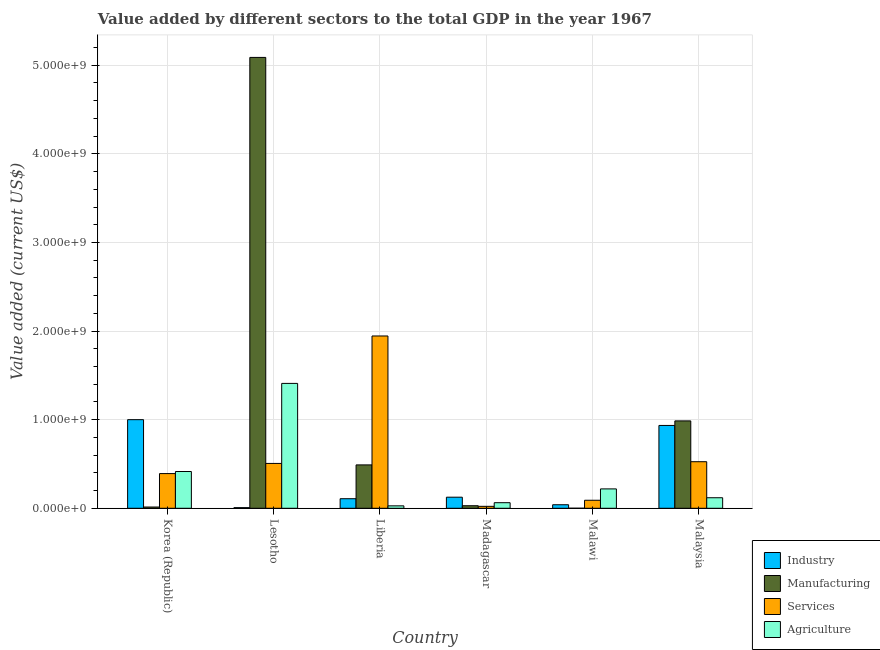How many different coloured bars are there?
Your response must be concise. 4. Are the number of bars on each tick of the X-axis equal?
Make the answer very short. Yes. How many bars are there on the 5th tick from the left?
Make the answer very short. 4. How many bars are there on the 5th tick from the right?
Make the answer very short. 4. What is the label of the 6th group of bars from the left?
Provide a succinct answer. Malaysia. In how many cases, is the number of bars for a given country not equal to the number of legend labels?
Your answer should be compact. 0. What is the value added by industrial sector in Lesotho?
Your answer should be compact. 6.99e+06. Across all countries, what is the maximum value added by industrial sector?
Provide a succinct answer. 1.00e+09. Across all countries, what is the minimum value added by industrial sector?
Offer a terse response. 6.99e+06. In which country was the value added by agricultural sector maximum?
Offer a very short reply. Lesotho. In which country was the value added by services sector minimum?
Give a very brief answer. Madagascar. What is the total value added by agricultural sector in the graph?
Provide a short and direct response. 2.25e+09. What is the difference between the value added by services sector in Korea (Republic) and that in Madagascar?
Keep it short and to the point. 3.70e+08. What is the difference between the value added by agricultural sector in Lesotho and the value added by industrial sector in Malawi?
Provide a short and direct response. 1.37e+09. What is the average value added by services sector per country?
Provide a short and direct response. 5.80e+08. What is the difference between the value added by manufacturing sector and value added by agricultural sector in Liberia?
Offer a terse response. 4.62e+08. In how many countries, is the value added by agricultural sector greater than 200000000 US$?
Ensure brevity in your answer.  3. What is the ratio of the value added by services sector in Liberia to that in Madagascar?
Offer a terse response. 88.78. Is the value added by manufacturing sector in Lesotho less than that in Malawi?
Make the answer very short. No. What is the difference between the highest and the second highest value added by services sector?
Your response must be concise. 1.42e+09. What is the difference between the highest and the lowest value added by industrial sector?
Give a very brief answer. 9.93e+08. In how many countries, is the value added by agricultural sector greater than the average value added by agricultural sector taken over all countries?
Your answer should be very brief. 2. Is the sum of the value added by industrial sector in Lesotho and Malawi greater than the maximum value added by services sector across all countries?
Offer a very short reply. No. Is it the case that in every country, the sum of the value added by industrial sector and value added by agricultural sector is greater than the sum of value added by manufacturing sector and value added by services sector?
Make the answer very short. No. What does the 4th bar from the left in Malaysia represents?
Offer a very short reply. Agriculture. What does the 3rd bar from the right in Madagascar represents?
Your answer should be compact. Manufacturing. How many bars are there?
Your answer should be very brief. 24. How many countries are there in the graph?
Make the answer very short. 6. What is the difference between two consecutive major ticks on the Y-axis?
Make the answer very short. 1.00e+09. Are the values on the major ticks of Y-axis written in scientific E-notation?
Your answer should be very brief. Yes. Does the graph contain any zero values?
Provide a short and direct response. No. Where does the legend appear in the graph?
Keep it short and to the point. Bottom right. How many legend labels are there?
Ensure brevity in your answer.  4. What is the title of the graph?
Offer a very short reply. Value added by different sectors to the total GDP in the year 1967. What is the label or title of the Y-axis?
Your response must be concise. Value added (current US$). What is the Value added (current US$) in Industry in Korea (Republic)?
Offer a terse response. 1.00e+09. What is the Value added (current US$) of Manufacturing in Korea (Republic)?
Make the answer very short. 1.41e+07. What is the Value added (current US$) of Services in Korea (Republic)?
Provide a succinct answer. 3.91e+08. What is the Value added (current US$) in Agriculture in Korea (Republic)?
Your response must be concise. 4.15e+08. What is the Value added (current US$) of Industry in Lesotho?
Keep it short and to the point. 6.99e+06. What is the Value added (current US$) in Manufacturing in Lesotho?
Your response must be concise. 5.09e+09. What is the Value added (current US$) of Services in Lesotho?
Provide a succinct answer. 5.06e+08. What is the Value added (current US$) in Agriculture in Lesotho?
Your answer should be compact. 1.41e+09. What is the Value added (current US$) in Industry in Liberia?
Keep it short and to the point. 1.08e+08. What is the Value added (current US$) of Manufacturing in Liberia?
Keep it short and to the point. 4.89e+08. What is the Value added (current US$) in Services in Liberia?
Offer a terse response. 1.94e+09. What is the Value added (current US$) of Agriculture in Liberia?
Your answer should be compact. 2.73e+07. What is the Value added (current US$) in Industry in Madagascar?
Offer a very short reply. 1.25e+08. What is the Value added (current US$) in Manufacturing in Madagascar?
Offer a terse response. 2.87e+07. What is the Value added (current US$) in Services in Madagascar?
Make the answer very short. 2.19e+07. What is the Value added (current US$) of Agriculture in Madagascar?
Ensure brevity in your answer.  6.28e+07. What is the Value added (current US$) of Industry in Malawi?
Provide a short and direct response. 3.98e+07. What is the Value added (current US$) of Manufacturing in Malawi?
Your answer should be compact. 2.76e+05. What is the Value added (current US$) of Services in Malawi?
Keep it short and to the point. 9.03e+07. What is the Value added (current US$) of Agriculture in Malawi?
Your response must be concise. 2.19e+08. What is the Value added (current US$) in Industry in Malaysia?
Ensure brevity in your answer.  9.35e+08. What is the Value added (current US$) of Manufacturing in Malaysia?
Provide a short and direct response. 9.86e+08. What is the Value added (current US$) in Services in Malaysia?
Offer a very short reply. 5.25e+08. What is the Value added (current US$) of Agriculture in Malaysia?
Ensure brevity in your answer.  1.19e+08. Across all countries, what is the maximum Value added (current US$) in Industry?
Provide a succinct answer. 1.00e+09. Across all countries, what is the maximum Value added (current US$) in Manufacturing?
Offer a terse response. 5.09e+09. Across all countries, what is the maximum Value added (current US$) in Services?
Provide a succinct answer. 1.94e+09. Across all countries, what is the maximum Value added (current US$) of Agriculture?
Offer a terse response. 1.41e+09. Across all countries, what is the minimum Value added (current US$) of Industry?
Your response must be concise. 6.99e+06. Across all countries, what is the minimum Value added (current US$) in Manufacturing?
Ensure brevity in your answer.  2.76e+05. Across all countries, what is the minimum Value added (current US$) in Services?
Provide a succinct answer. 2.19e+07. Across all countries, what is the minimum Value added (current US$) in Agriculture?
Provide a short and direct response. 2.73e+07. What is the total Value added (current US$) of Industry in the graph?
Your answer should be very brief. 2.21e+09. What is the total Value added (current US$) of Manufacturing in the graph?
Ensure brevity in your answer.  6.61e+09. What is the total Value added (current US$) of Services in the graph?
Ensure brevity in your answer.  3.48e+09. What is the total Value added (current US$) of Agriculture in the graph?
Ensure brevity in your answer.  2.25e+09. What is the difference between the Value added (current US$) of Industry in Korea (Republic) and that in Lesotho?
Ensure brevity in your answer.  9.93e+08. What is the difference between the Value added (current US$) of Manufacturing in Korea (Republic) and that in Lesotho?
Your answer should be very brief. -5.07e+09. What is the difference between the Value added (current US$) of Services in Korea (Republic) and that in Lesotho?
Your response must be concise. -1.15e+08. What is the difference between the Value added (current US$) of Agriculture in Korea (Republic) and that in Lesotho?
Your answer should be very brief. -9.94e+08. What is the difference between the Value added (current US$) of Industry in Korea (Republic) and that in Liberia?
Your response must be concise. 8.92e+08. What is the difference between the Value added (current US$) of Manufacturing in Korea (Republic) and that in Liberia?
Make the answer very short. -4.75e+08. What is the difference between the Value added (current US$) in Services in Korea (Republic) and that in Liberia?
Your response must be concise. -1.55e+09. What is the difference between the Value added (current US$) in Agriculture in Korea (Republic) and that in Liberia?
Your answer should be very brief. 3.88e+08. What is the difference between the Value added (current US$) in Industry in Korea (Republic) and that in Madagascar?
Your response must be concise. 8.75e+08. What is the difference between the Value added (current US$) of Manufacturing in Korea (Republic) and that in Madagascar?
Provide a short and direct response. -1.46e+07. What is the difference between the Value added (current US$) in Services in Korea (Republic) and that in Madagascar?
Ensure brevity in your answer.  3.70e+08. What is the difference between the Value added (current US$) in Agriculture in Korea (Republic) and that in Madagascar?
Provide a succinct answer. 3.52e+08. What is the difference between the Value added (current US$) of Industry in Korea (Republic) and that in Malawi?
Your answer should be compact. 9.60e+08. What is the difference between the Value added (current US$) in Manufacturing in Korea (Republic) and that in Malawi?
Provide a short and direct response. 1.38e+07. What is the difference between the Value added (current US$) in Services in Korea (Republic) and that in Malawi?
Give a very brief answer. 3.01e+08. What is the difference between the Value added (current US$) of Agriculture in Korea (Republic) and that in Malawi?
Make the answer very short. 1.96e+08. What is the difference between the Value added (current US$) of Industry in Korea (Republic) and that in Malaysia?
Keep it short and to the point. 6.53e+07. What is the difference between the Value added (current US$) of Manufacturing in Korea (Republic) and that in Malaysia?
Provide a short and direct response. -9.72e+08. What is the difference between the Value added (current US$) in Services in Korea (Republic) and that in Malaysia?
Your answer should be very brief. -1.34e+08. What is the difference between the Value added (current US$) in Agriculture in Korea (Republic) and that in Malaysia?
Keep it short and to the point. 2.96e+08. What is the difference between the Value added (current US$) of Industry in Lesotho and that in Liberia?
Make the answer very short. -1.01e+08. What is the difference between the Value added (current US$) in Manufacturing in Lesotho and that in Liberia?
Your answer should be compact. 4.60e+09. What is the difference between the Value added (current US$) of Services in Lesotho and that in Liberia?
Keep it short and to the point. -1.44e+09. What is the difference between the Value added (current US$) in Agriculture in Lesotho and that in Liberia?
Your answer should be compact. 1.38e+09. What is the difference between the Value added (current US$) in Industry in Lesotho and that in Madagascar?
Offer a very short reply. -1.18e+08. What is the difference between the Value added (current US$) of Manufacturing in Lesotho and that in Madagascar?
Ensure brevity in your answer.  5.06e+09. What is the difference between the Value added (current US$) in Services in Lesotho and that in Madagascar?
Your answer should be very brief. 4.84e+08. What is the difference between the Value added (current US$) of Agriculture in Lesotho and that in Madagascar?
Make the answer very short. 1.35e+09. What is the difference between the Value added (current US$) in Industry in Lesotho and that in Malawi?
Keep it short and to the point. -3.28e+07. What is the difference between the Value added (current US$) of Manufacturing in Lesotho and that in Malawi?
Ensure brevity in your answer.  5.09e+09. What is the difference between the Value added (current US$) of Services in Lesotho and that in Malawi?
Your answer should be compact. 4.16e+08. What is the difference between the Value added (current US$) of Agriculture in Lesotho and that in Malawi?
Ensure brevity in your answer.  1.19e+09. What is the difference between the Value added (current US$) of Industry in Lesotho and that in Malaysia?
Your answer should be compact. -9.28e+08. What is the difference between the Value added (current US$) of Manufacturing in Lesotho and that in Malaysia?
Keep it short and to the point. 4.10e+09. What is the difference between the Value added (current US$) of Services in Lesotho and that in Malaysia?
Give a very brief answer. -1.93e+07. What is the difference between the Value added (current US$) of Agriculture in Lesotho and that in Malaysia?
Your answer should be compact. 1.29e+09. What is the difference between the Value added (current US$) in Industry in Liberia and that in Madagascar?
Offer a very short reply. -1.71e+07. What is the difference between the Value added (current US$) of Manufacturing in Liberia and that in Madagascar?
Ensure brevity in your answer.  4.61e+08. What is the difference between the Value added (current US$) of Services in Liberia and that in Madagascar?
Offer a terse response. 1.92e+09. What is the difference between the Value added (current US$) in Agriculture in Liberia and that in Madagascar?
Your answer should be very brief. -3.56e+07. What is the difference between the Value added (current US$) in Industry in Liberia and that in Malawi?
Your answer should be very brief. 6.81e+07. What is the difference between the Value added (current US$) of Manufacturing in Liberia and that in Malawi?
Your answer should be very brief. 4.89e+08. What is the difference between the Value added (current US$) in Services in Liberia and that in Malawi?
Give a very brief answer. 1.85e+09. What is the difference between the Value added (current US$) in Agriculture in Liberia and that in Malawi?
Your answer should be compact. -1.91e+08. What is the difference between the Value added (current US$) of Industry in Liberia and that in Malaysia?
Provide a succinct answer. -8.27e+08. What is the difference between the Value added (current US$) in Manufacturing in Liberia and that in Malaysia?
Your answer should be compact. -4.97e+08. What is the difference between the Value added (current US$) of Services in Liberia and that in Malaysia?
Offer a terse response. 1.42e+09. What is the difference between the Value added (current US$) of Agriculture in Liberia and that in Malaysia?
Your answer should be very brief. -9.15e+07. What is the difference between the Value added (current US$) of Industry in Madagascar and that in Malawi?
Offer a very short reply. 8.52e+07. What is the difference between the Value added (current US$) of Manufacturing in Madagascar and that in Malawi?
Give a very brief answer. 2.85e+07. What is the difference between the Value added (current US$) in Services in Madagascar and that in Malawi?
Provide a short and direct response. -6.84e+07. What is the difference between the Value added (current US$) of Agriculture in Madagascar and that in Malawi?
Make the answer very short. -1.56e+08. What is the difference between the Value added (current US$) in Industry in Madagascar and that in Malaysia?
Your response must be concise. -8.10e+08. What is the difference between the Value added (current US$) in Manufacturing in Madagascar and that in Malaysia?
Offer a very short reply. -9.57e+08. What is the difference between the Value added (current US$) of Services in Madagascar and that in Malaysia?
Provide a succinct answer. -5.03e+08. What is the difference between the Value added (current US$) in Agriculture in Madagascar and that in Malaysia?
Offer a terse response. -5.59e+07. What is the difference between the Value added (current US$) of Industry in Malawi and that in Malaysia?
Make the answer very short. -8.95e+08. What is the difference between the Value added (current US$) in Manufacturing in Malawi and that in Malaysia?
Your response must be concise. -9.86e+08. What is the difference between the Value added (current US$) in Services in Malawi and that in Malaysia?
Offer a terse response. -4.35e+08. What is the difference between the Value added (current US$) in Agriculture in Malawi and that in Malaysia?
Your answer should be very brief. 9.98e+07. What is the difference between the Value added (current US$) of Industry in Korea (Republic) and the Value added (current US$) of Manufacturing in Lesotho?
Give a very brief answer. -4.09e+09. What is the difference between the Value added (current US$) in Industry in Korea (Republic) and the Value added (current US$) in Services in Lesotho?
Give a very brief answer. 4.94e+08. What is the difference between the Value added (current US$) of Industry in Korea (Republic) and the Value added (current US$) of Agriculture in Lesotho?
Offer a terse response. -4.09e+08. What is the difference between the Value added (current US$) of Manufacturing in Korea (Republic) and the Value added (current US$) of Services in Lesotho?
Provide a short and direct response. -4.92e+08. What is the difference between the Value added (current US$) in Manufacturing in Korea (Republic) and the Value added (current US$) in Agriculture in Lesotho?
Your answer should be compact. -1.40e+09. What is the difference between the Value added (current US$) of Services in Korea (Republic) and the Value added (current US$) of Agriculture in Lesotho?
Your response must be concise. -1.02e+09. What is the difference between the Value added (current US$) of Industry in Korea (Republic) and the Value added (current US$) of Manufacturing in Liberia?
Your answer should be very brief. 5.11e+08. What is the difference between the Value added (current US$) of Industry in Korea (Republic) and the Value added (current US$) of Services in Liberia?
Provide a short and direct response. -9.45e+08. What is the difference between the Value added (current US$) of Industry in Korea (Republic) and the Value added (current US$) of Agriculture in Liberia?
Offer a terse response. 9.73e+08. What is the difference between the Value added (current US$) in Manufacturing in Korea (Republic) and the Value added (current US$) in Services in Liberia?
Provide a succinct answer. -1.93e+09. What is the difference between the Value added (current US$) in Manufacturing in Korea (Republic) and the Value added (current US$) in Agriculture in Liberia?
Your answer should be compact. -1.32e+07. What is the difference between the Value added (current US$) in Services in Korea (Republic) and the Value added (current US$) in Agriculture in Liberia?
Your response must be concise. 3.64e+08. What is the difference between the Value added (current US$) of Industry in Korea (Republic) and the Value added (current US$) of Manufacturing in Madagascar?
Offer a terse response. 9.71e+08. What is the difference between the Value added (current US$) in Industry in Korea (Republic) and the Value added (current US$) in Services in Madagascar?
Offer a terse response. 9.78e+08. What is the difference between the Value added (current US$) of Industry in Korea (Republic) and the Value added (current US$) of Agriculture in Madagascar?
Provide a short and direct response. 9.37e+08. What is the difference between the Value added (current US$) in Manufacturing in Korea (Republic) and the Value added (current US$) in Services in Madagascar?
Provide a succinct answer. -7.80e+06. What is the difference between the Value added (current US$) of Manufacturing in Korea (Republic) and the Value added (current US$) of Agriculture in Madagascar?
Your answer should be very brief. -4.87e+07. What is the difference between the Value added (current US$) in Services in Korea (Republic) and the Value added (current US$) in Agriculture in Madagascar?
Offer a terse response. 3.29e+08. What is the difference between the Value added (current US$) of Industry in Korea (Republic) and the Value added (current US$) of Manufacturing in Malawi?
Ensure brevity in your answer.  1.00e+09. What is the difference between the Value added (current US$) in Industry in Korea (Republic) and the Value added (current US$) in Services in Malawi?
Your answer should be very brief. 9.10e+08. What is the difference between the Value added (current US$) of Industry in Korea (Republic) and the Value added (current US$) of Agriculture in Malawi?
Offer a terse response. 7.81e+08. What is the difference between the Value added (current US$) of Manufacturing in Korea (Republic) and the Value added (current US$) of Services in Malawi?
Offer a very short reply. -7.62e+07. What is the difference between the Value added (current US$) in Manufacturing in Korea (Republic) and the Value added (current US$) in Agriculture in Malawi?
Offer a terse response. -2.04e+08. What is the difference between the Value added (current US$) of Services in Korea (Republic) and the Value added (current US$) of Agriculture in Malawi?
Make the answer very short. 1.73e+08. What is the difference between the Value added (current US$) of Industry in Korea (Republic) and the Value added (current US$) of Manufacturing in Malaysia?
Your answer should be compact. 1.39e+07. What is the difference between the Value added (current US$) of Industry in Korea (Republic) and the Value added (current US$) of Services in Malaysia?
Provide a short and direct response. 4.75e+08. What is the difference between the Value added (current US$) of Industry in Korea (Republic) and the Value added (current US$) of Agriculture in Malaysia?
Provide a short and direct response. 8.81e+08. What is the difference between the Value added (current US$) of Manufacturing in Korea (Republic) and the Value added (current US$) of Services in Malaysia?
Your answer should be very brief. -5.11e+08. What is the difference between the Value added (current US$) in Manufacturing in Korea (Republic) and the Value added (current US$) in Agriculture in Malaysia?
Keep it short and to the point. -1.05e+08. What is the difference between the Value added (current US$) in Services in Korea (Republic) and the Value added (current US$) in Agriculture in Malaysia?
Provide a succinct answer. 2.73e+08. What is the difference between the Value added (current US$) of Industry in Lesotho and the Value added (current US$) of Manufacturing in Liberia?
Your response must be concise. -4.82e+08. What is the difference between the Value added (current US$) of Industry in Lesotho and the Value added (current US$) of Services in Liberia?
Provide a succinct answer. -1.94e+09. What is the difference between the Value added (current US$) of Industry in Lesotho and the Value added (current US$) of Agriculture in Liberia?
Your response must be concise. -2.03e+07. What is the difference between the Value added (current US$) of Manufacturing in Lesotho and the Value added (current US$) of Services in Liberia?
Give a very brief answer. 3.14e+09. What is the difference between the Value added (current US$) of Manufacturing in Lesotho and the Value added (current US$) of Agriculture in Liberia?
Give a very brief answer. 5.06e+09. What is the difference between the Value added (current US$) in Services in Lesotho and the Value added (current US$) in Agriculture in Liberia?
Keep it short and to the point. 4.79e+08. What is the difference between the Value added (current US$) in Industry in Lesotho and the Value added (current US$) in Manufacturing in Madagascar?
Offer a very short reply. -2.18e+07. What is the difference between the Value added (current US$) of Industry in Lesotho and the Value added (current US$) of Services in Madagascar?
Keep it short and to the point. -1.49e+07. What is the difference between the Value added (current US$) in Industry in Lesotho and the Value added (current US$) in Agriculture in Madagascar?
Keep it short and to the point. -5.59e+07. What is the difference between the Value added (current US$) in Manufacturing in Lesotho and the Value added (current US$) in Services in Madagascar?
Keep it short and to the point. 5.07e+09. What is the difference between the Value added (current US$) in Manufacturing in Lesotho and the Value added (current US$) in Agriculture in Madagascar?
Offer a terse response. 5.03e+09. What is the difference between the Value added (current US$) of Services in Lesotho and the Value added (current US$) of Agriculture in Madagascar?
Provide a short and direct response. 4.43e+08. What is the difference between the Value added (current US$) in Industry in Lesotho and the Value added (current US$) in Manufacturing in Malawi?
Offer a terse response. 6.72e+06. What is the difference between the Value added (current US$) of Industry in Lesotho and the Value added (current US$) of Services in Malawi?
Provide a succinct answer. -8.33e+07. What is the difference between the Value added (current US$) of Industry in Lesotho and the Value added (current US$) of Agriculture in Malawi?
Provide a short and direct response. -2.12e+08. What is the difference between the Value added (current US$) in Manufacturing in Lesotho and the Value added (current US$) in Services in Malawi?
Your answer should be very brief. 5.00e+09. What is the difference between the Value added (current US$) of Manufacturing in Lesotho and the Value added (current US$) of Agriculture in Malawi?
Give a very brief answer. 4.87e+09. What is the difference between the Value added (current US$) of Services in Lesotho and the Value added (current US$) of Agriculture in Malawi?
Offer a terse response. 2.88e+08. What is the difference between the Value added (current US$) of Industry in Lesotho and the Value added (current US$) of Manufacturing in Malaysia?
Provide a short and direct response. -9.79e+08. What is the difference between the Value added (current US$) of Industry in Lesotho and the Value added (current US$) of Services in Malaysia?
Provide a succinct answer. -5.18e+08. What is the difference between the Value added (current US$) of Industry in Lesotho and the Value added (current US$) of Agriculture in Malaysia?
Offer a terse response. -1.12e+08. What is the difference between the Value added (current US$) in Manufacturing in Lesotho and the Value added (current US$) in Services in Malaysia?
Your answer should be compact. 4.56e+09. What is the difference between the Value added (current US$) of Manufacturing in Lesotho and the Value added (current US$) of Agriculture in Malaysia?
Your answer should be very brief. 4.97e+09. What is the difference between the Value added (current US$) of Services in Lesotho and the Value added (current US$) of Agriculture in Malaysia?
Give a very brief answer. 3.87e+08. What is the difference between the Value added (current US$) of Industry in Liberia and the Value added (current US$) of Manufacturing in Madagascar?
Keep it short and to the point. 7.91e+07. What is the difference between the Value added (current US$) in Industry in Liberia and the Value added (current US$) in Services in Madagascar?
Give a very brief answer. 8.59e+07. What is the difference between the Value added (current US$) in Industry in Liberia and the Value added (current US$) in Agriculture in Madagascar?
Provide a short and direct response. 4.50e+07. What is the difference between the Value added (current US$) in Manufacturing in Liberia and the Value added (current US$) in Services in Madagascar?
Your answer should be compact. 4.68e+08. What is the difference between the Value added (current US$) of Manufacturing in Liberia and the Value added (current US$) of Agriculture in Madagascar?
Provide a short and direct response. 4.27e+08. What is the difference between the Value added (current US$) in Services in Liberia and the Value added (current US$) in Agriculture in Madagascar?
Ensure brevity in your answer.  1.88e+09. What is the difference between the Value added (current US$) of Industry in Liberia and the Value added (current US$) of Manufacturing in Malawi?
Your answer should be compact. 1.08e+08. What is the difference between the Value added (current US$) in Industry in Liberia and the Value added (current US$) in Services in Malawi?
Offer a very short reply. 1.75e+07. What is the difference between the Value added (current US$) in Industry in Liberia and the Value added (current US$) in Agriculture in Malawi?
Your answer should be compact. -1.11e+08. What is the difference between the Value added (current US$) in Manufacturing in Liberia and the Value added (current US$) in Services in Malawi?
Offer a very short reply. 3.99e+08. What is the difference between the Value added (current US$) of Manufacturing in Liberia and the Value added (current US$) of Agriculture in Malawi?
Give a very brief answer. 2.71e+08. What is the difference between the Value added (current US$) of Services in Liberia and the Value added (current US$) of Agriculture in Malawi?
Offer a terse response. 1.73e+09. What is the difference between the Value added (current US$) in Industry in Liberia and the Value added (current US$) in Manufacturing in Malaysia?
Your response must be concise. -8.78e+08. What is the difference between the Value added (current US$) in Industry in Liberia and the Value added (current US$) in Services in Malaysia?
Ensure brevity in your answer.  -4.18e+08. What is the difference between the Value added (current US$) in Industry in Liberia and the Value added (current US$) in Agriculture in Malaysia?
Provide a short and direct response. -1.09e+07. What is the difference between the Value added (current US$) of Manufacturing in Liberia and the Value added (current US$) of Services in Malaysia?
Your answer should be compact. -3.59e+07. What is the difference between the Value added (current US$) of Manufacturing in Liberia and the Value added (current US$) of Agriculture in Malaysia?
Give a very brief answer. 3.71e+08. What is the difference between the Value added (current US$) in Services in Liberia and the Value added (current US$) in Agriculture in Malaysia?
Offer a very short reply. 1.83e+09. What is the difference between the Value added (current US$) in Industry in Madagascar and the Value added (current US$) in Manufacturing in Malawi?
Make the answer very short. 1.25e+08. What is the difference between the Value added (current US$) of Industry in Madagascar and the Value added (current US$) of Services in Malawi?
Your answer should be compact. 3.46e+07. What is the difference between the Value added (current US$) in Industry in Madagascar and the Value added (current US$) in Agriculture in Malawi?
Offer a very short reply. -9.36e+07. What is the difference between the Value added (current US$) of Manufacturing in Madagascar and the Value added (current US$) of Services in Malawi?
Provide a short and direct response. -6.16e+07. What is the difference between the Value added (current US$) of Manufacturing in Madagascar and the Value added (current US$) of Agriculture in Malawi?
Make the answer very short. -1.90e+08. What is the difference between the Value added (current US$) in Services in Madagascar and the Value added (current US$) in Agriculture in Malawi?
Your answer should be very brief. -1.97e+08. What is the difference between the Value added (current US$) in Industry in Madagascar and the Value added (current US$) in Manufacturing in Malaysia?
Your response must be concise. -8.61e+08. What is the difference between the Value added (current US$) of Industry in Madagascar and the Value added (current US$) of Services in Malaysia?
Offer a terse response. -4.00e+08. What is the difference between the Value added (current US$) in Industry in Madagascar and the Value added (current US$) in Agriculture in Malaysia?
Your answer should be very brief. 6.20e+06. What is the difference between the Value added (current US$) in Manufacturing in Madagascar and the Value added (current US$) in Services in Malaysia?
Your response must be concise. -4.97e+08. What is the difference between the Value added (current US$) in Manufacturing in Madagascar and the Value added (current US$) in Agriculture in Malaysia?
Your answer should be compact. -9.00e+07. What is the difference between the Value added (current US$) in Services in Madagascar and the Value added (current US$) in Agriculture in Malaysia?
Provide a succinct answer. -9.68e+07. What is the difference between the Value added (current US$) in Industry in Malawi and the Value added (current US$) in Manufacturing in Malaysia?
Make the answer very short. -9.46e+08. What is the difference between the Value added (current US$) of Industry in Malawi and the Value added (current US$) of Services in Malaysia?
Provide a short and direct response. -4.86e+08. What is the difference between the Value added (current US$) of Industry in Malawi and the Value added (current US$) of Agriculture in Malaysia?
Give a very brief answer. -7.90e+07. What is the difference between the Value added (current US$) of Manufacturing in Malawi and the Value added (current US$) of Services in Malaysia?
Ensure brevity in your answer.  -5.25e+08. What is the difference between the Value added (current US$) of Manufacturing in Malawi and the Value added (current US$) of Agriculture in Malaysia?
Provide a succinct answer. -1.18e+08. What is the difference between the Value added (current US$) in Services in Malawi and the Value added (current US$) in Agriculture in Malaysia?
Give a very brief answer. -2.84e+07. What is the average Value added (current US$) in Industry per country?
Keep it short and to the point. 3.69e+08. What is the average Value added (current US$) of Manufacturing per country?
Make the answer very short. 1.10e+09. What is the average Value added (current US$) in Services per country?
Give a very brief answer. 5.80e+08. What is the average Value added (current US$) of Agriculture per country?
Offer a very short reply. 3.75e+08. What is the difference between the Value added (current US$) in Industry and Value added (current US$) in Manufacturing in Korea (Republic)?
Your answer should be very brief. 9.86e+08. What is the difference between the Value added (current US$) in Industry and Value added (current US$) in Services in Korea (Republic)?
Provide a short and direct response. 6.09e+08. What is the difference between the Value added (current US$) of Industry and Value added (current US$) of Agriculture in Korea (Republic)?
Your answer should be very brief. 5.85e+08. What is the difference between the Value added (current US$) of Manufacturing and Value added (current US$) of Services in Korea (Republic)?
Offer a terse response. -3.77e+08. What is the difference between the Value added (current US$) of Manufacturing and Value added (current US$) of Agriculture in Korea (Republic)?
Offer a terse response. -4.01e+08. What is the difference between the Value added (current US$) in Services and Value added (current US$) in Agriculture in Korea (Republic)?
Keep it short and to the point. -2.34e+07. What is the difference between the Value added (current US$) of Industry and Value added (current US$) of Manufacturing in Lesotho?
Offer a terse response. -5.08e+09. What is the difference between the Value added (current US$) in Industry and Value added (current US$) in Services in Lesotho?
Ensure brevity in your answer.  -4.99e+08. What is the difference between the Value added (current US$) in Industry and Value added (current US$) in Agriculture in Lesotho?
Offer a very short reply. -1.40e+09. What is the difference between the Value added (current US$) in Manufacturing and Value added (current US$) in Services in Lesotho?
Ensure brevity in your answer.  4.58e+09. What is the difference between the Value added (current US$) of Manufacturing and Value added (current US$) of Agriculture in Lesotho?
Provide a short and direct response. 3.68e+09. What is the difference between the Value added (current US$) in Services and Value added (current US$) in Agriculture in Lesotho?
Give a very brief answer. -9.03e+08. What is the difference between the Value added (current US$) in Industry and Value added (current US$) in Manufacturing in Liberia?
Your answer should be compact. -3.82e+08. What is the difference between the Value added (current US$) in Industry and Value added (current US$) in Services in Liberia?
Your response must be concise. -1.84e+09. What is the difference between the Value added (current US$) in Industry and Value added (current US$) in Agriculture in Liberia?
Offer a very short reply. 8.06e+07. What is the difference between the Value added (current US$) in Manufacturing and Value added (current US$) in Services in Liberia?
Your answer should be very brief. -1.46e+09. What is the difference between the Value added (current US$) of Manufacturing and Value added (current US$) of Agriculture in Liberia?
Your answer should be compact. 4.62e+08. What is the difference between the Value added (current US$) of Services and Value added (current US$) of Agriculture in Liberia?
Provide a succinct answer. 1.92e+09. What is the difference between the Value added (current US$) in Industry and Value added (current US$) in Manufacturing in Madagascar?
Offer a terse response. 9.62e+07. What is the difference between the Value added (current US$) in Industry and Value added (current US$) in Services in Madagascar?
Provide a short and direct response. 1.03e+08. What is the difference between the Value added (current US$) in Industry and Value added (current US$) in Agriculture in Madagascar?
Ensure brevity in your answer.  6.21e+07. What is the difference between the Value added (current US$) of Manufacturing and Value added (current US$) of Services in Madagascar?
Make the answer very short. 6.84e+06. What is the difference between the Value added (current US$) of Manufacturing and Value added (current US$) of Agriculture in Madagascar?
Offer a terse response. -3.41e+07. What is the difference between the Value added (current US$) of Services and Value added (current US$) of Agriculture in Madagascar?
Ensure brevity in your answer.  -4.09e+07. What is the difference between the Value added (current US$) of Industry and Value added (current US$) of Manufacturing in Malawi?
Your response must be concise. 3.95e+07. What is the difference between the Value added (current US$) in Industry and Value added (current US$) in Services in Malawi?
Keep it short and to the point. -5.06e+07. What is the difference between the Value added (current US$) of Industry and Value added (current US$) of Agriculture in Malawi?
Provide a succinct answer. -1.79e+08. What is the difference between the Value added (current US$) of Manufacturing and Value added (current US$) of Services in Malawi?
Make the answer very short. -9.01e+07. What is the difference between the Value added (current US$) of Manufacturing and Value added (current US$) of Agriculture in Malawi?
Your response must be concise. -2.18e+08. What is the difference between the Value added (current US$) of Services and Value added (current US$) of Agriculture in Malawi?
Provide a short and direct response. -1.28e+08. What is the difference between the Value added (current US$) in Industry and Value added (current US$) in Manufacturing in Malaysia?
Make the answer very short. -5.14e+07. What is the difference between the Value added (current US$) in Industry and Value added (current US$) in Services in Malaysia?
Make the answer very short. 4.09e+08. What is the difference between the Value added (current US$) in Industry and Value added (current US$) in Agriculture in Malaysia?
Your answer should be compact. 8.16e+08. What is the difference between the Value added (current US$) in Manufacturing and Value added (current US$) in Services in Malaysia?
Offer a very short reply. 4.61e+08. What is the difference between the Value added (current US$) in Manufacturing and Value added (current US$) in Agriculture in Malaysia?
Your answer should be compact. 8.67e+08. What is the difference between the Value added (current US$) of Services and Value added (current US$) of Agriculture in Malaysia?
Ensure brevity in your answer.  4.07e+08. What is the ratio of the Value added (current US$) of Industry in Korea (Republic) to that in Lesotho?
Keep it short and to the point. 143. What is the ratio of the Value added (current US$) of Manufacturing in Korea (Republic) to that in Lesotho?
Offer a terse response. 0. What is the ratio of the Value added (current US$) in Services in Korea (Republic) to that in Lesotho?
Offer a very short reply. 0.77. What is the ratio of the Value added (current US$) of Agriculture in Korea (Republic) to that in Lesotho?
Provide a short and direct response. 0.29. What is the ratio of the Value added (current US$) of Industry in Korea (Republic) to that in Liberia?
Offer a terse response. 9.27. What is the ratio of the Value added (current US$) of Manufacturing in Korea (Republic) to that in Liberia?
Give a very brief answer. 0.03. What is the ratio of the Value added (current US$) of Services in Korea (Republic) to that in Liberia?
Keep it short and to the point. 0.2. What is the ratio of the Value added (current US$) in Agriculture in Korea (Republic) to that in Liberia?
Provide a short and direct response. 15.2. What is the ratio of the Value added (current US$) in Industry in Korea (Republic) to that in Madagascar?
Provide a short and direct response. 8. What is the ratio of the Value added (current US$) in Manufacturing in Korea (Republic) to that in Madagascar?
Give a very brief answer. 0.49. What is the ratio of the Value added (current US$) of Services in Korea (Republic) to that in Madagascar?
Your answer should be compact. 17.87. What is the ratio of the Value added (current US$) in Agriculture in Korea (Republic) to that in Madagascar?
Your response must be concise. 6.6. What is the ratio of the Value added (current US$) in Industry in Korea (Republic) to that in Malawi?
Keep it short and to the point. 25.15. What is the ratio of the Value added (current US$) in Manufacturing in Korea (Republic) to that in Malawi?
Keep it short and to the point. 51.08. What is the ratio of the Value added (current US$) of Services in Korea (Republic) to that in Malawi?
Your answer should be very brief. 4.33. What is the ratio of the Value added (current US$) in Agriculture in Korea (Republic) to that in Malawi?
Ensure brevity in your answer.  1.9. What is the ratio of the Value added (current US$) of Industry in Korea (Republic) to that in Malaysia?
Keep it short and to the point. 1.07. What is the ratio of the Value added (current US$) of Manufacturing in Korea (Republic) to that in Malaysia?
Provide a short and direct response. 0.01. What is the ratio of the Value added (current US$) in Services in Korea (Republic) to that in Malaysia?
Your answer should be very brief. 0.74. What is the ratio of the Value added (current US$) in Agriculture in Korea (Republic) to that in Malaysia?
Offer a very short reply. 3.49. What is the ratio of the Value added (current US$) in Industry in Lesotho to that in Liberia?
Your response must be concise. 0.06. What is the ratio of the Value added (current US$) of Manufacturing in Lesotho to that in Liberia?
Provide a short and direct response. 10.4. What is the ratio of the Value added (current US$) in Services in Lesotho to that in Liberia?
Provide a short and direct response. 0.26. What is the ratio of the Value added (current US$) in Agriculture in Lesotho to that in Liberia?
Provide a succinct answer. 51.65. What is the ratio of the Value added (current US$) in Industry in Lesotho to that in Madagascar?
Your answer should be very brief. 0.06. What is the ratio of the Value added (current US$) of Manufacturing in Lesotho to that in Madagascar?
Make the answer very short. 177.02. What is the ratio of the Value added (current US$) of Services in Lesotho to that in Madagascar?
Offer a very short reply. 23.11. What is the ratio of the Value added (current US$) in Agriculture in Lesotho to that in Madagascar?
Ensure brevity in your answer.  22.43. What is the ratio of the Value added (current US$) in Industry in Lesotho to that in Malawi?
Offer a terse response. 0.18. What is the ratio of the Value added (current US$) in Manufacturing in Lesotho to that in Malawi?
Ensure brevity in your answer.  1.84e+04. What is the ratio of the Value added (current US$) in Services in Lesotho to that in Malawi?
Keep it short and to the point. 5.6. What is the ratio of the Value added (current US$) in Agriculture in Lesotho to that in Malawi?
Your answer should be compact. 6.45. What is the ratio of the Value added (current US$) in Industry in Lesotho to that in Malaysia?
Provide a short and direct response. 0.01. What is the ratio of the Value added (current US$) of Manufacturing in Lesotho to that in Malaysia?
Provide a succinct answer. 5.16. What is the ratio of the Value added (current US$) in Services in Lesotho to that in Malaysia?
Provide a short and direct response. 0.96. What is the ratio of the Value added (current US$) in Agriculture in Lesotho to that in Malaysia?
Your answer should be very brief. 11.87. What is the ratio of the Value added (current US$) of Industry in Liberia to that in Madagascar?
Keep it short and to the point. 0.86. What is the ratio of the Value added (current US$) of Manufacturing in Liberia to that in Madagascar?
Provide a succinct answer. 17.03. What is the ratio of the Value added (current US$) in Services in Liberia to that in Madagascar?
Your answer should be compact. 88.78. What is the ratio of the Value added (current US$) of Agriculture in Liberia to that in Madagascar?
Your answer should be very brief. 0.43. What is the ratio of the Value added (current US$) of Industry in Liberia to that in Malawi?
Keep it short and to the point. 2.71. What is the ratio of the Value added (current US$) of Manufacturing in Liberia to that in Malawi?
Keep it short and to the point. 1772.41. What is the ratio of the Value added (current US$) of Services in Liberia to that in Malawi?
Your answer should be very brief. 21.53. What is the ratio of the Value added (current US$) in Agriculture in Liberia to that in Malawi?
Your answer should be very brief. 0.12. What is the ratio of the Value added (current US$) of Industry in Liberia to that in Malaysia?
Make the answer very short. 0.12. What is the ratio of the Value added (current US$) in Manufacturing in Liberia to that in Malaysia?
Provide a succinct answer. 0.5. What is the ratio of the Value added (current US$) of Services in Liberia to that in Malaysia?
Provide a succinct answer. 3.7. What is the ratio of the Value added (current US$) of Agriculture in Liberia to that in Malaysia?
Offer a terse response. 0.23. What is the ratio of the Value added (current US$) of Industry in Madagascar to that in Malawi?
Give a very brief answer. 3.14. What is the ratio of the Value added (current US$) in Manufacturing in Madagascar to that in Malawi?
Keep it short and to the point. 104.08. What is the ratio of the Value added (current US$) in Services in Madagascar to that in Malawi?
Your response must be concise. 0.24. What is the ratio of the Value added (current US$) of Agriculture in Madagascar to that in Malawi?
Provide a short and direct response. 0.29. What is the ratio of the Value added (current US$) in Industry in Madagascar to that in Malaysia?
Offer a terse response. 0.13. What is the ratio of the Value added (current US$) of Manufacturing in Madagascar to that in Malaysia?
Give a very brief answer. 0.03. What is the ratio of the Value added (current US$) of Services in Madagascar to that in Malaysia?
Your answer should be compact. 0.04. What is the ratio of the Value added (current US$) of Agriculture in Madagascar to that in Malaysia?
Provide a short and direct response. 0.53. What is the ratio of the Value added (current US$) of Industry in Malawi to that in Malaysia?
Your answer should be very brief. 0.04. What is the ratio of the Value added (current US$) in Manufacturing in Malawi to that in Malaysia?
Ensure brevity in your answer.  0. What is the ratio of the Value added (current US$) of Services in Malawi to that in Malaysia?
Offer a terse response. 0.17. What is the ratio of the Value added (current US$) in Agriculture in Malawi to that in Malaysia?
Your answer should be very brief. 1.84. What is the difference between the highest and the second highest Value added (current US$) of Industry?
Provide a short and direct response. 6.53e+07. What is the difference between the highest and the second highest Value added (current US$) in Manufacturing?
Offer a very short reply. 4.10e+09. What is the difference between the highest and the second highest Value added (current US$) of Services?
Your answer should be very brief. 1.42e+09. What is the difference between the highest and the second highest Value added (current US$) of Agriculture?
Provide a short and direct response. 9.94e+08. What is the difference between the highest and the lowest Value added (current US$) in Industry?
Make the answer very short. 9.93e+08. What is the difference between the highest and the lowest Value added (current US$) of Manufacturing?
Make the answer very short. 5.09e+09. What is the difference between the highest and the lowest Value added (current US$) of Services?
Keep it short and to the point. 1.92e+09. What is the difference between the highest and the lowest Value added (current US$) in Agriculture?
Make the answer very short. 1.38e+09. 